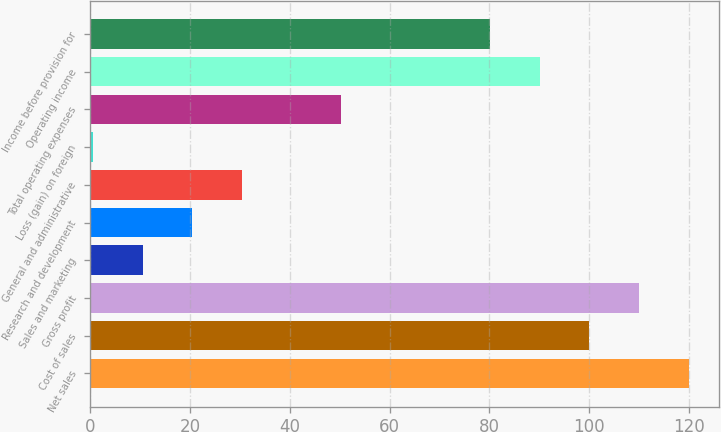Convert chart to OTSL. <chart><loc_0><loc_0><loc_500><loc_500><bar_chart><fcel>Net sales<fcel>Cost of sales<fcel>Gross profit<fcel>Sales and marketing<fcel>Research and development<fcel>General and administrative<fcel>Loss (gain) on foreign<fcel>Total operating expenses<fcel>Operating income<fcel>Income before provision for<nl><fcel>119.88<fcel>100<fcel>109.94<fcel>10.54<fcel>20.48<fcel>30.42<fcel>0.6<fcel>50.3<fcel>90.06<fcel>80.12<nl></chart> 